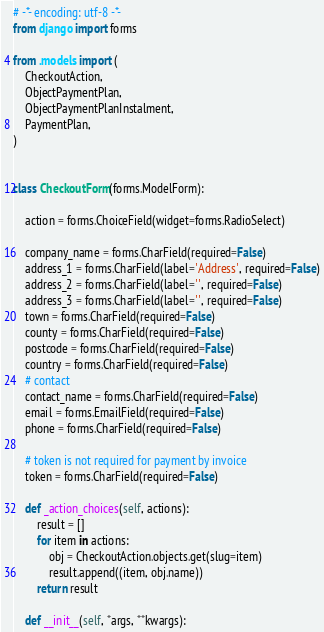Convert code to text. <code><loc_0><loc_0><loc_500><loc_500><_Python_># -*- encoding: utf-8 -*-
from django import forms

from .models import (
    CheckoutAction,
    ObjectPaymentPlan,
    ObjectPaymentPlanInstalment,
    PaymentPlan,
)


class CheckoutForm(forms.ModelForm):

    action = forms.ChoiceField(widget=forms.RadioSelect)

    company_name = forms.CharField(required=False)
    address_1 = forms.CharField(label='Address', required=False)
    address_2 = forms.CharField(label='', required=False)
    address_3 = forms.CharField(label='', required=False)
    town = forms.CharField(required=False)
    county = forms.CharField(required=False)
    postcode = forms.CharField(required=False)
    country = forms.CharField(required=False)
    # contact
    contact_name = forms.CharField(required=False)
    email = forms.EmailField(required=False)
    phone = forms.CharField(required=False)

    # token is not required for payment by invoice
    token = forms.CharField(required=False)

    def _action_choices(self, actions):
        result = []
        for item in actions:
            obj = CheckoutAction.objects.get(slug=item)
            result.append((item, obj.name))
        return result

    def __init__(self, *args, **kwargs):</code> 